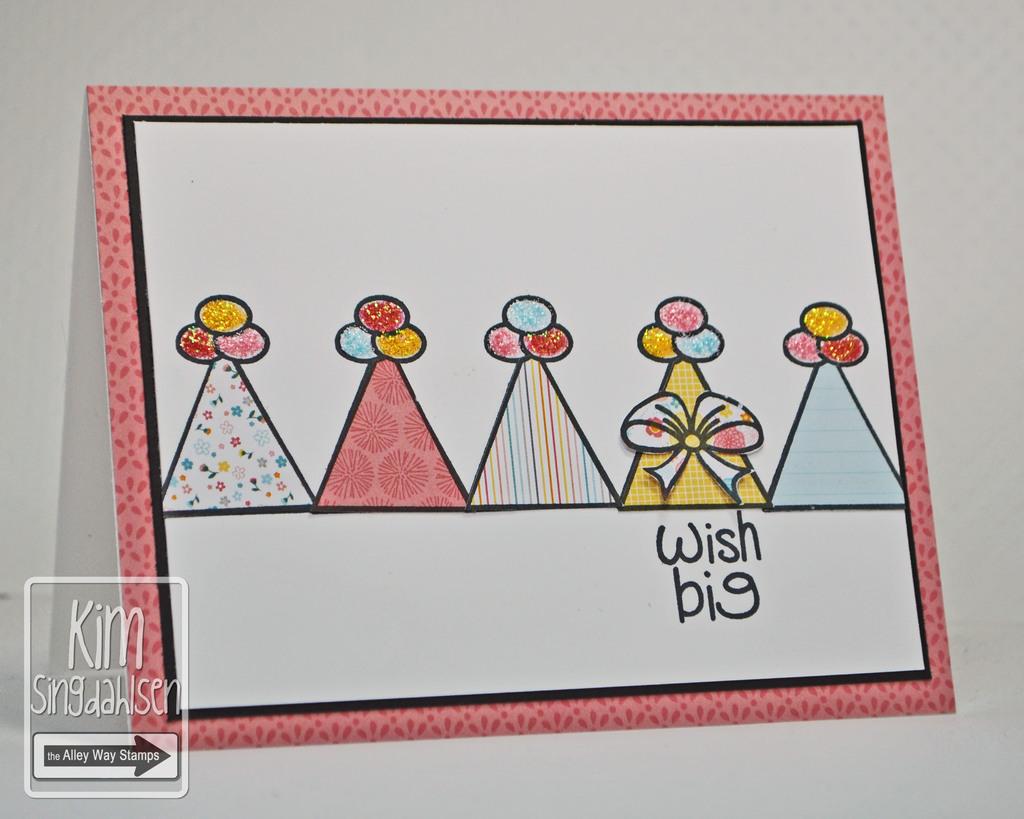What is it telling you to do?
Give a very brief answer. Wish big. 